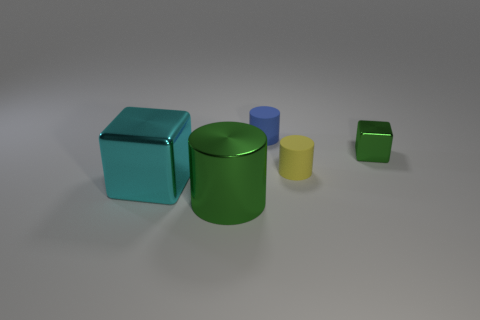Can you tell me the different colors and shapes present in this image? Certainly! The image features a collection of geometric shapes with different colors. There's a large turquoise-blue cube, a big green cylinder, a smaller blue cylinder, a tiny yellow cylinder, and a small green cube.  What could these objects represent if they were symbols? If we consider them as symbols, the various objects might represent elements in a simplistic cityscape, with the cubes as buildings and the cylinders as water towers or storage tanks. 